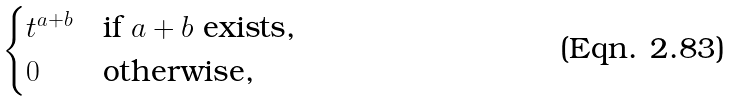<formula> <loc_0><loc_0><loc_500><loc_500>\begin{cases} t ^ { a + b } & \text {if $a+b$ exists,} \\ 0 & \text {otherwise,} \end{cases}</formula> 